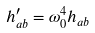<formula> <loc_0><loc_0><loc_500><loc_500>h ^ { \prime } _ { a b } = \omega _ { 0 } ^ { 4 } h _ { a b }</formula> 